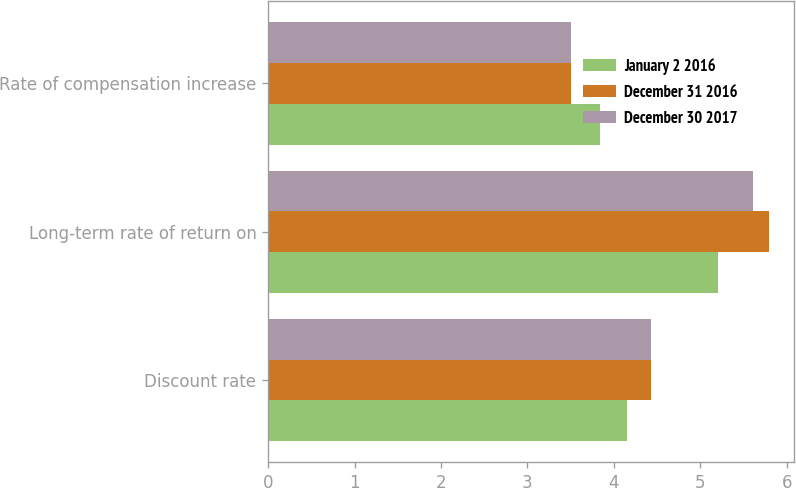<chart> <loc_0><loc_0><loc_500><loc_500><stacked_bar_chart><ecel><fcel>Discount rate<fcel>Long-term rate of return on<fcel>Rate of compensation increase<nl><fcel>January 2 2016<fcel>4.15<fcel>5.21<fcel>3.84<nl><fcel>December 31 2016<fcel>4.43<fcel>5.8<fcel>3.51<nl><fcel>December 30 2017<fcel>4.43<fcel>5.61<fcel>3.51<nl></chart> 